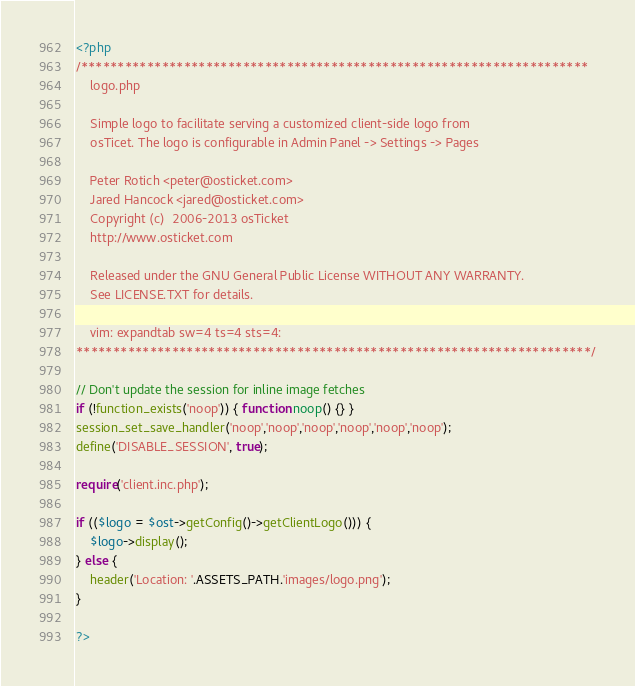Convert code to text. <code><loc_0><loc_0><loc_500><loc_500><_PHP_><?php
/*********************************************************************
    logo.php

    Simple logo to facilitate serving a customized client-side logo from
    osTicet. The logo is configurable in Admin Panel -> Settings -> Pages

    Peter Rotich <peter@osticket.com>
    Jared Hancock <jared@osticket.com>
    Copyright (c)  2006-2013 osTicket
    http://www.osticket.com

    Released under the GNU General Public License WITHOUT ANY WARRANTY.
    See LICENSE.TXT for details.

    vim: expandtab sw=4 ts=4 sts=4:
**********************************************************************/

// Don't update the session for inline image fetches
if (!function_exists('noop')) { function noop() {} }
session_set_save_handler('noop','noop','noop','noop','noop','noop');
define('DISABLE_SESSION', true);

require('client.inc.php');

if (($logo = $ost->getConfig()->getClientLogo())) {
    $logo->display();
} else {
    header('Location: '.ASSETS_PATH.'images/logo.png');
}

?>
</code> 